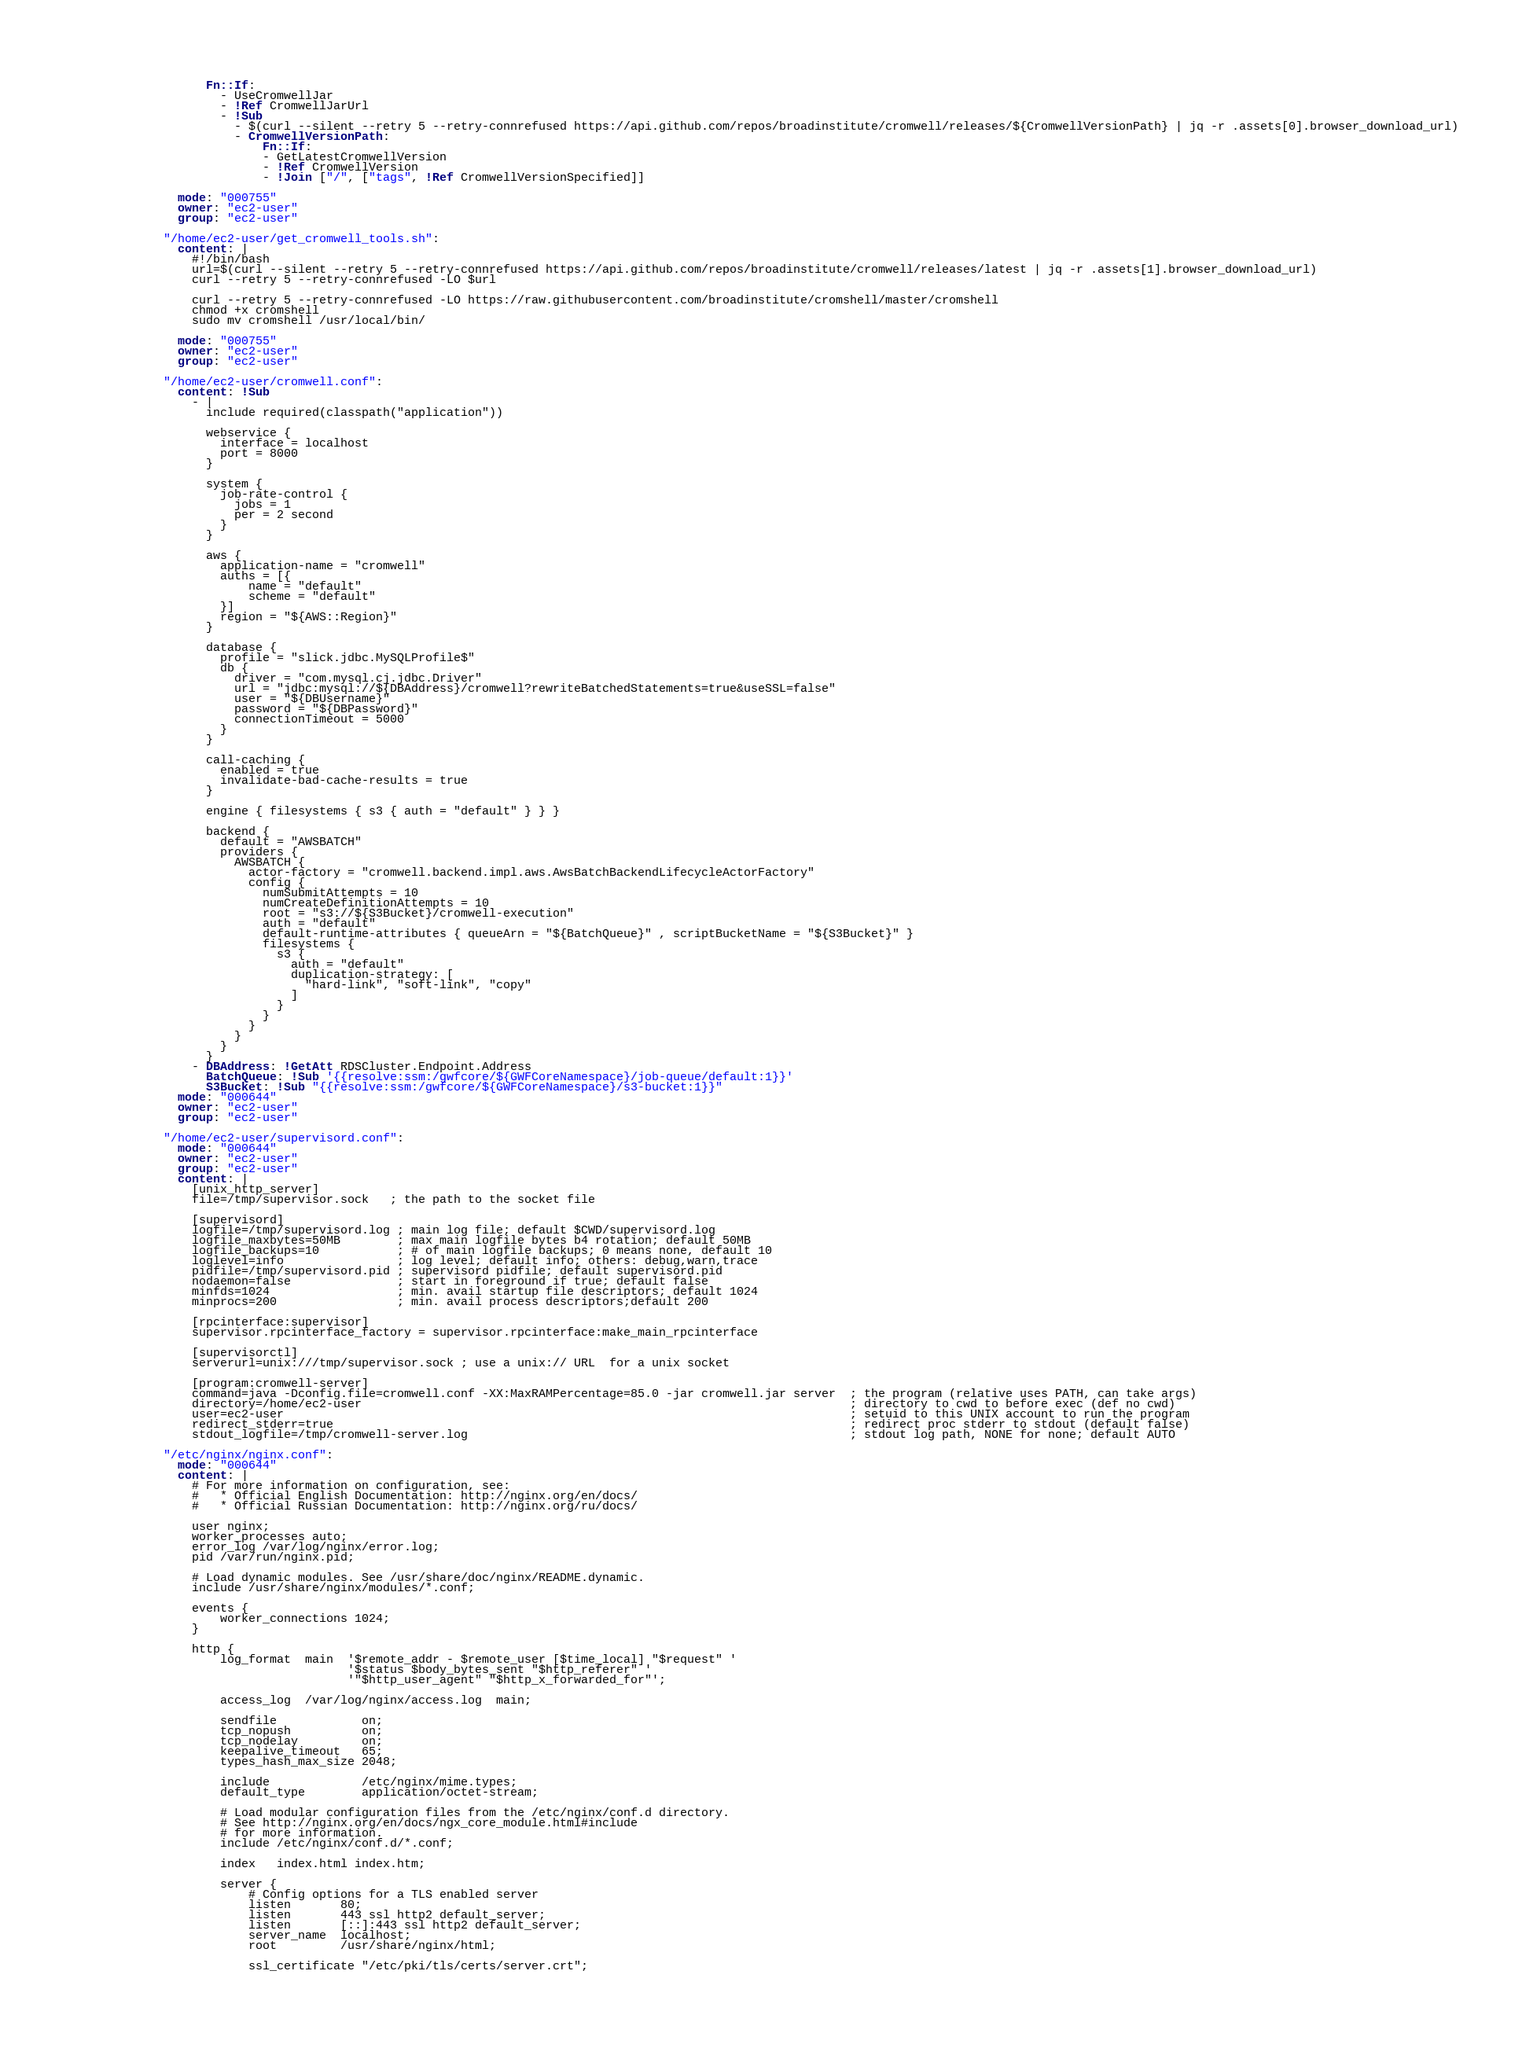Convert code to text. <code><loc_0><loc_0><loc_500><loc_500><_YAML_>                  Fn::If:
                    - UseCromwellJar
                    - !Ref CromwellJarUrl
                    - !Sub
                      - $(curl --silent --retry 5 --retry-connrefused https://api.github.com/repos/broadinstitute/cromwell/releases/${CromwellVersionPath} | jq -r .assets[0].browser_download_url)
                      - CromwellVersionPath:
                          Fn::If:
                          - GetLatestCromwellVersion
                          - !Ref CromwellVersion
                          - !Join ["/", ["tags", !Ref CromwellVersionSpecified]]

              mode: "000755"
              owner: "ec2-user"
              group: "ec2-user"

            "/home/ec2-user/get_cromwell_tools.sh":
              content: |
                #!/bin/bash
                url=$(curl --silent --retry 5 --retry-connrefused https://api.github.com/repos/broadinstitute/cromwell/releases/latest | jq -r .assets[1].browser_download_url)
                curl --retry 5 --retry-connrefused -LO $url

                curl --retry 5 --retry-connrefused -LO https://raw.githubusercontent.com/broadinstitute/cromshell/master/cromshell
                chmod +x cromshell
                sudo mv cromshell /usr/local/bin/

              mode: "000755"
              owner: "ec2-user"
              group: "ec2-user"

            "/home/ec2-user/cromwell.conf":
              content: !Sub
                - |
                  include required(classpath("application"))

                  webservice {
                    interface = localhost
                    port = 8000
                  }

                  system {
                    job-rate-control {
                      jobs = 1
                      per = 2 second
                    }
                  }

                  aws {
                    application-name = "cromwell"
                    auths = [{
                        name = "default"
                        scheme = "default"
                    }]
                    region = "${AWS::Region}"
                  }

                  database {
                    profile = "slick.jdbc.MySQLProfile$"
                    db {
                      driver = "com.mysql.cj.jdbc.Driver"
                      url = "jdbc:mysql://${DBAddress}/cromwell?rewriteBatchedStatements=true&useSSL=false"
                      user = "${DBUsername}"
                      password = "${DBPassword}"
                      connectionTimeout = 5000
                    }
                  }

                  call-caching {
                    enabled = true
                    invalidate-bad-cache-results = true
                  }

                  engine { filesystems { s3 { auth = "default" } } }

                  backend {
                    default = "AWSBATCH"
                    providers {
                      AWSBATCH {
                        actor-factory = "cromwell.backend.impl.aws.AwsBatchBackendLifecycleActorFactory"
                        config {
                          numSubmitAttempts = 10
                          numCreateDefinitionAttempts = 10
                          root = "s3://${S3Bucket}/cromwell-execution"
                          auth = "default"
                          default-runtime-attributes { queueArn = "${BatchQueue}" , scriptBucketName = "${S3Bucket}" }
                          filesystems { 
                            s3 { 
                              auth = "default"
                              duplication-strategy: [
                                "hard-link", "soft-link", "copy"
                              ]
                            } 
                          }
                        }
                      }
                    }
                  }
                - DBAddress: !GetAtt RDSCluster.Endpoint.Address
                  BatchQueue: !Sub '{{resolve:ssm:/gwfcore/${GWFCoreNamespace}/job-queue/default:1}}'
                  S3Bucket: !Sub "{{resolve:ssm:/gwfcore/${GWFCoreNamespace}/s3-bucket:1}}"
              mode: "000644"
              owner: "ec2-user"
              group: "ec2-user"

            "/home/ec2-user/supervisord.conf":
              mode: "000644"
              owner: "ec2-user"
              group: "ec2-user"
              content: |
                [unix_http_server]
                file=/tmp/supervisor.sock   ; the path to the socket file
                
                [supervisord]
                logfile=/tmp/supervisord.log ; main log file; default $CWD/supervisord.log
                logfile_maxbytes=50MB        ; max main logfile bytes b4 rotation; default 50MB
                logfile_backups=10           ; # of main logfile backups; 0 means none, default 10
                loglevel=info                ; log level; default info; others: debug,warn,trace
                pidfile=/tmp/supervisord.pid ; supervisord pidfile; default supervisord.pid
                nodaemon=false               ; start in foreground if true; default false
                minfds=1024                  ; min. avail startup file descriptors; default 1024
                minprocs=200                 ; min. avail process descriptors;default 200
                
                [rpcinterface:supervisor]
                supervisor.rpcinterface_factory = supervisor.rpcinterface:make_main_rpcinterface

                [supervisorctl]
                serverurl=unix:///tmp/supervisor.sock ; use a unix:// URL  for a unix socket

                [program:cromwell-server]
                command=java -Dconfig.file=cromwell.conf -XX:MaxRAMPercentage=85.0 -jar cromwell.jar server  ; the program (relative uses PATH, can take args)
                directory=/home/ec2-user                                                                     ; directory to cwd to before exec (def no cwd)
                user=ec2-user                                                                                ; setuid to this UNIX account to run the program
                redirect_stderr=true                                                                         ; redirect proc stderr to stdout (default false)
                stdout_logfile=/tmp/cromwell-server.log                                                      ; stdout log path, NONE for none; default AUTO
          
            "/etc/nginx/nginx.conf":
              mode: "000644"
              content: |
                # For more information on configuration, see:
                #   * Official English Documentation: http://nginx.org/en/docs/
                #   * Official Russian Documentation: http://nginx.org/ru/docs/

                user nginx;
                worker_processes auto;
                error_log /var/log/nginx/error.log;
                pid /var/run/nginx.pid;

                # Load dynamic modules. See /usr/share/doc/nginx/README.dynamic.
                include /usr/share/nginx/modules/*.conf;

                events {
                    worker_connections 1024;
                }

                http {
                    log_format  main  '$remote_addr - $remote_user [$time_local] "$request" '
                                      '$status $body_bytes_sent "$http_referer" '
                                      '"$http_user_agent" "$http_x_forwarded_for"';

                    access_log  /var/log/nginx/access.log  main;

                    sendfile            on;
                    tcp_nopush          on;
                    tcp_nodelay         on;
                    keepalive_timeout   65;
                    types_hash_max_size 2048;

                    include             /etc/nginx/mime.types;
                    default_type        application/octet-stream;

                    # Load modular configuration files from the /etc/nginx/conf.d directory.
                    # See http://nginx.org/en/docs/ngx_core_module.html#include
                    # for more information.
                    include /etc/nginx/conf.d/*.conf;

                    index   index.html index.htm;

                    server {
                        # Config options for a TLS enabled server
                        listen       80;
                        listen       443 ssl http2 default_server;
                        listen       [::]:443 ssl http2 default_server;
                        server_name  localhost;
                        root         /usr/share/nginx/html;
                
                        ssl_certificate "/etc/pki/tls/certs/server.crt";</code> 